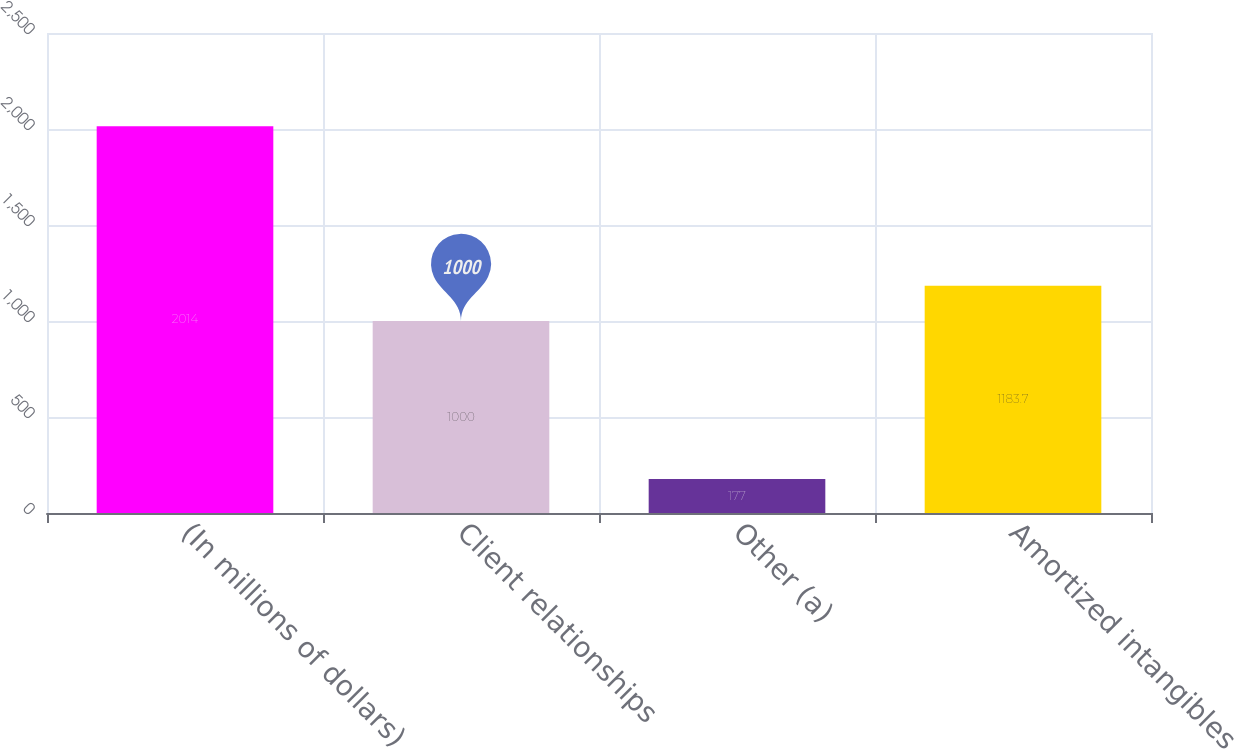Convert chart. <chart><loc_0><loc_0><loc_500><loc_500><bar_chart><fcel>(In millions of dollars)<fcel>Client relationships<fcel>Other (a)<fcel>Amortized intangibles<nl><fcel>2014<fcel>1000<fcel>177<fcel>1183.7<nl></chart> 